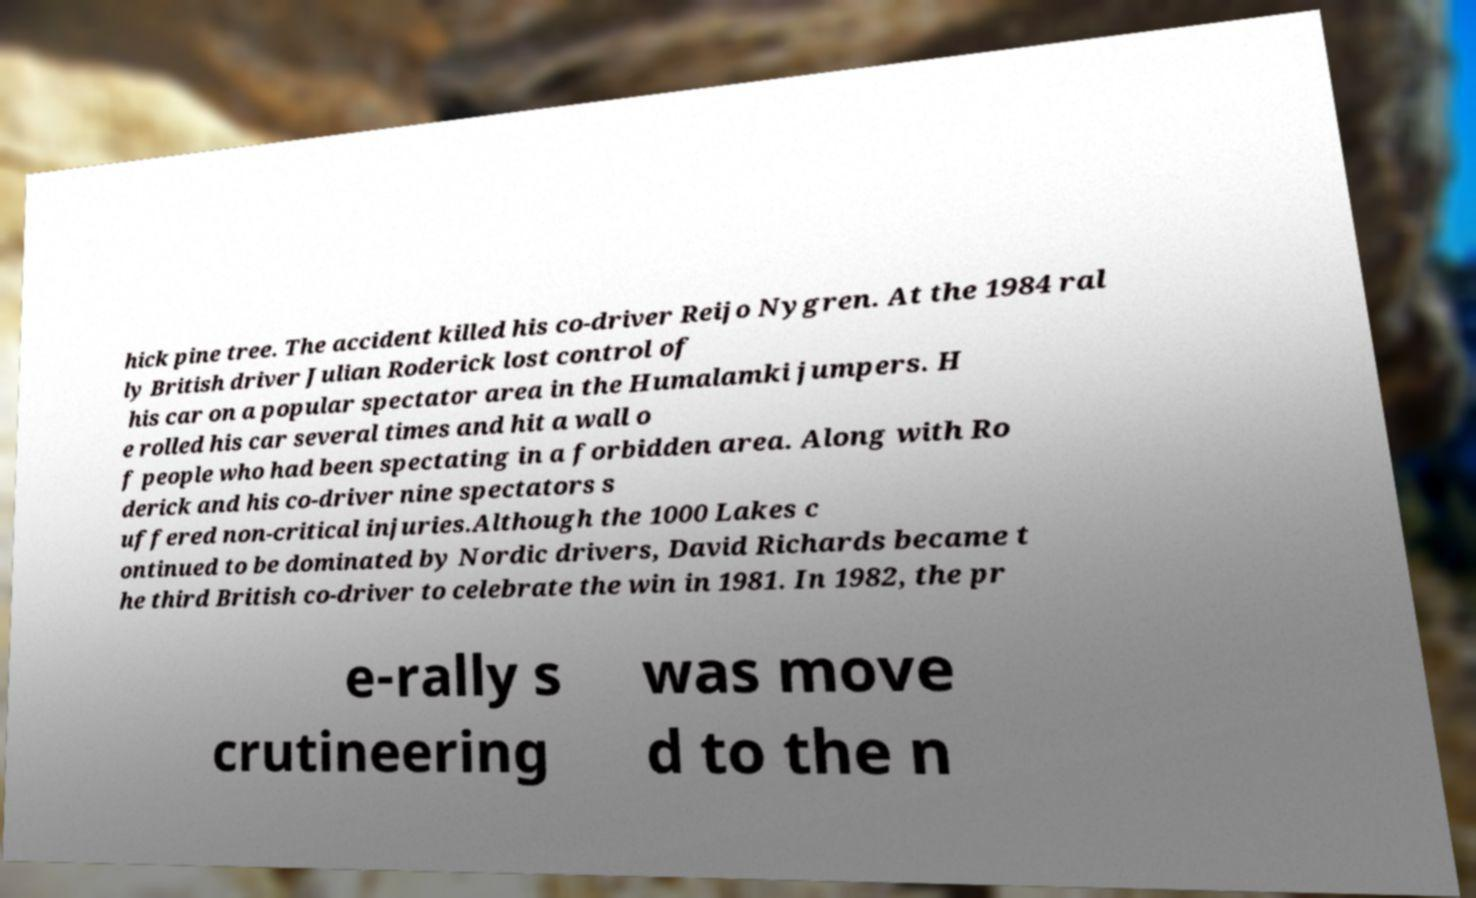Could you assist in decoding the text presented in this image and type it out clearly? hick pine tree. The accident killed his co-driver Reijo Nygren. At the 1984 ral ly British driver Julian Roderick lost control of his car on a popular spectator area in the Humalamki jumpers. H e rolled his car several times and hit a wall o f people who had been spectating in a forbidden area. Along with Ro derick and his co-driver nine spectators s uffered non-critical injuries.Although the 1000 Lakes c ontinued to be dominated by Nordic drivers, David Richards became t he third British co-driver to celebrate the win in 1981. In 1982, the pr e-rally s crutineering was move d to the n 